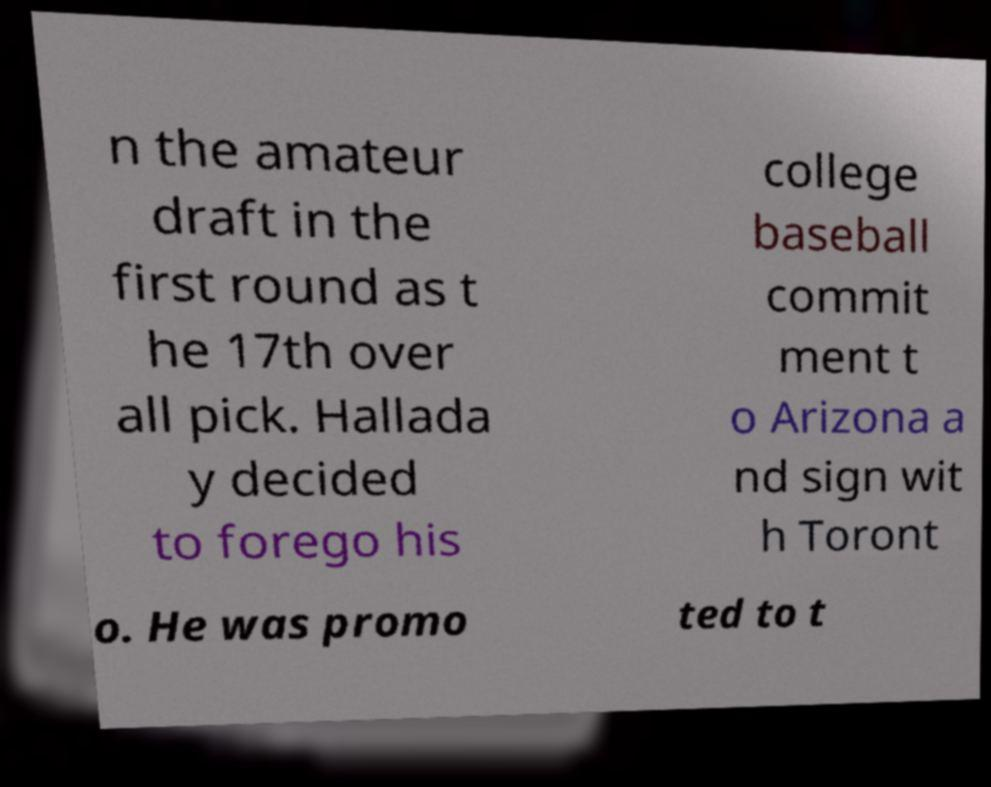Can you read and provide the text displayed in the image?This photo seems to have some interesting text. Can you extract and type it out for me? n the amateur draft in the first round as t he 17th over all pick. Hallada y decided to forego his college baseball commit ment t o Arizona a nd sign wit h Toront o. He was promo ted to t 